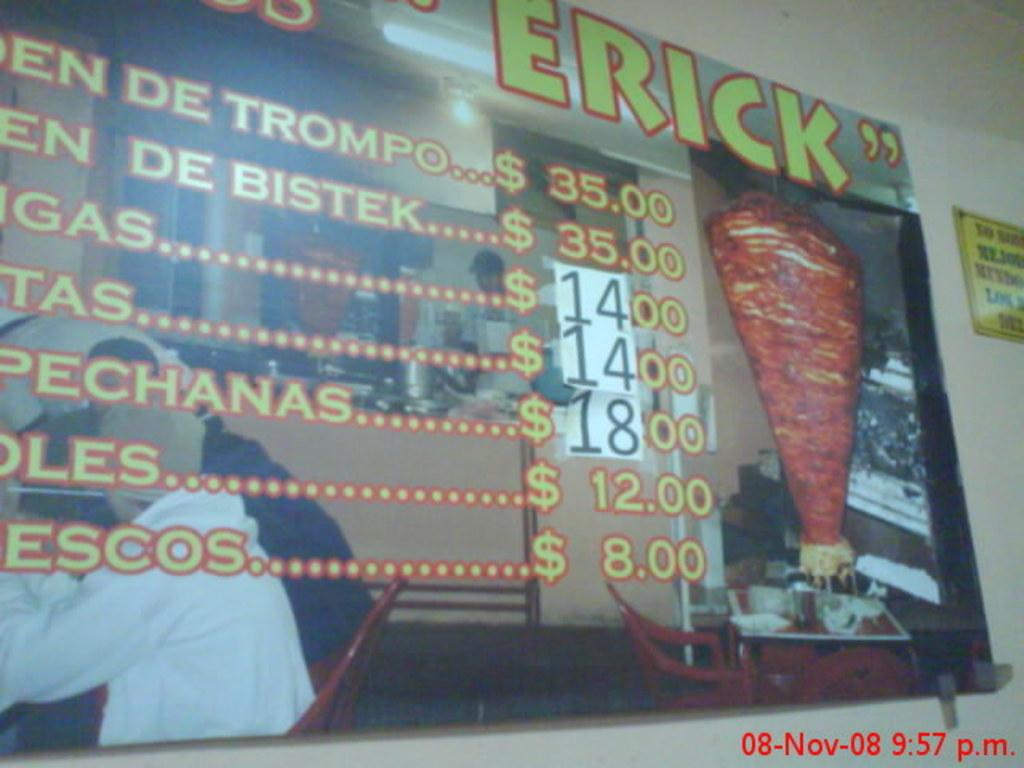<image>
Render a clear and concise summary of the photo. A large menu in a kebab shop showing prices ranging from $8.00 to $35.00 